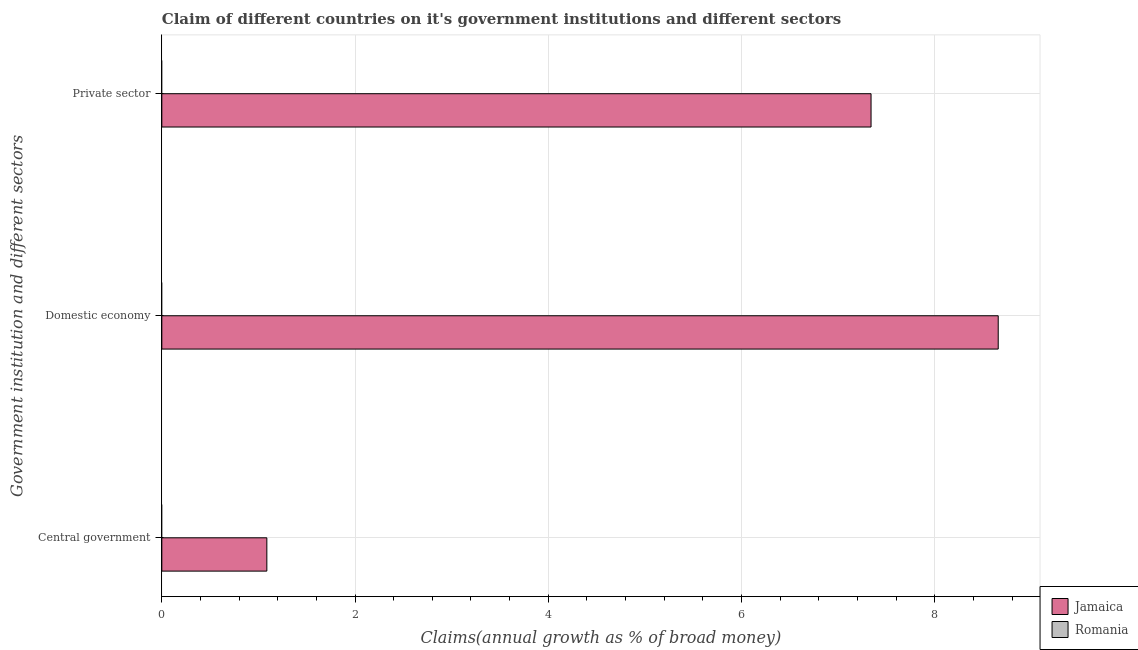How many different coloured bars are there?
Your answer should be compact. 1. Are the number of bars per tick equal to the number of legend labels?
Offer a terse response. No. What is the label of the 1st group of bars from the top?
Make the answer very short. Private sector. What is the percentage of claim on the central government in Jamaica?
Give a very brief answer. 1.09. Across all countries, what is the maximum percentage of claim on the domestic economy?
Provide a succinct answer. 8.66. In which country was the percentage of claim on the domestic economy maximum?
Offer a very short reply. Jamaica. What is the total percentage of claim on the central government in the graph?
Keep it short and to the point. 1.09. What is the difference between the percentage of claim on the central government in Romania and the percentage of claim on the private sector in Jamaica?
Provide a short and direct response. -7.34. What is the average percentage of claim on the private sector per country?
Your answer should be compact. 3.67. What is the difference between the percentage of claim on the private sector and percentage of claim on the central government in Jamaica?
Provide a short and direct response. 6.25. What is the difference between the highest and the lowest percentage of claim on the domestic economy?
Your answer should be compact. 8.66. Is it the case that in every country, the sum of the percentage of claim on the central government and percentage of claim on the domestic economy is greater than the percentage of claim on the private sector?
Provide a short and direct response. No. How many countries are there in the graph?
Give a very brief answer. 2. What is the difference between two consecutive major ticks on the X-axis?
Ensure brevity in your answer.  2. Does the graph contain grids?
Your answer should be very brief. Yes. Where does the legend appear in the graph?
Your answer should be very brief. Bottom right. How many legend labels are there?
Ensure brevity in your answer.  2. What is the title of the graph?
Keep it short and to the point. Claim of different countries on it's government institutions and different sectors. What is the label or title of the X-axis?
Offer a terse response. Claims(annual growth as % of broad money). What is the label or title of the Y-axis?
Ensure brevity in your answer.  Government institution and different sectors. What is the Claims(annual growth as % of broad money) of Jamaica in Central government?
Offer a very short reply. 1.09. What is the Claims(annual growth as % of broad money) of Jamaica in Domestic economy?
Offer a terse response. 8.66. What is the Claims(annual growth as % of broad money) in Romania in Domestic economy?
Offer a very short reply. 0. What is the Claims(annual growth as % of broad money) in Jamaica in Private sector?
Make the answer very short. 7.34. Across all Government institution and different sectors, what is the maximum Claims(annual growth as % of broad money) in Jamaica?
Your answer should be very brief. 8.66. Across all Government institution and different sectors, what is the minimum Claims(annual growth as % of broad money) of Jamaica?
Keep it short and to the point. 1.09. What is the total Claims(annual growth as % of broad money) of Jamaica in the graph?
Give a very brief answer. 17.09. What is the total Claims(annual growth as % of broad money) of Romania in the graph?
Offer a very short reply. 0. What is the difference between the Claims(annual growth as % of broad money) in Jamaica in Central government and that in Domestic economy?
Your response must be concise. -7.57. What is the difference between the Claims(annual growth as % of broad money) in Jamaica in Central government and that in Private sector?
Keep it short and to the point. -6.25. What is the difference between the Claims(annual growth as % of broad money) in Jamaica in Domestic economy and that in Private sector?
Give a very brief answer. 1.32. What is the average Claims(annual growth as % of broad money) of Jamaica per Government institution and different sectors?
Give a very brief answer. 5.7. What is the ratio of the Claims(annual growth as % of broad money) of Jamaica in Central government to that in Domestic economy?
Ensure brevity in your answer.  0.13. What is the ratio of the Claims(annual growth as % of broad money) of Jamaica in Central government to that in Private sector?
Give a very brief answer. 0.15. What is the ratio of the Claims(annual growth as % of broad money) of Jamaica in Domestic economy to that in Private sector?
Offer a terse response. 1.18. What is the difference between the highest and the second highest Claims(annual growth as % of broad money) of Jamaica?
Keep it short and to the point. 1.32. What is the difference between the highest and the lowest Claims(annual growth as % of broad money) in Jamaica?
Make the answer very short. 7.57. 